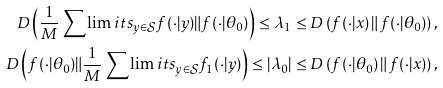Convert formula to latex. <formula><loc_0><loc_0><loc_500><loc_500>D \left ( \frac { 1 } { M } \sum \lim i t s _ { y \in \mathcal { S } } f ( \cdot | y ) \| f ( \cdot | \theta _ { 0 } ) \right ) \leq \lambda _ { 1 } \leq D \left ( f ( \cdot | x ) \, \| \, f ( \cdot | \theta _ { 0 } ) \right ) , \\ D \left ( f ( \cdot | \theta _ { 0 } ) \| \frac { 1 } { M } \sum \lim i t s _ { y \in \mathcal { S } } f _ { 1 } ( \cdot | y ) \right ) \leq | \lambda _ { 0 } | \leq D \left ( f ( \cdot | \theta _ { 0 } ) \, \| \, f ( \cdot | x ) \right ) ,</formula> 